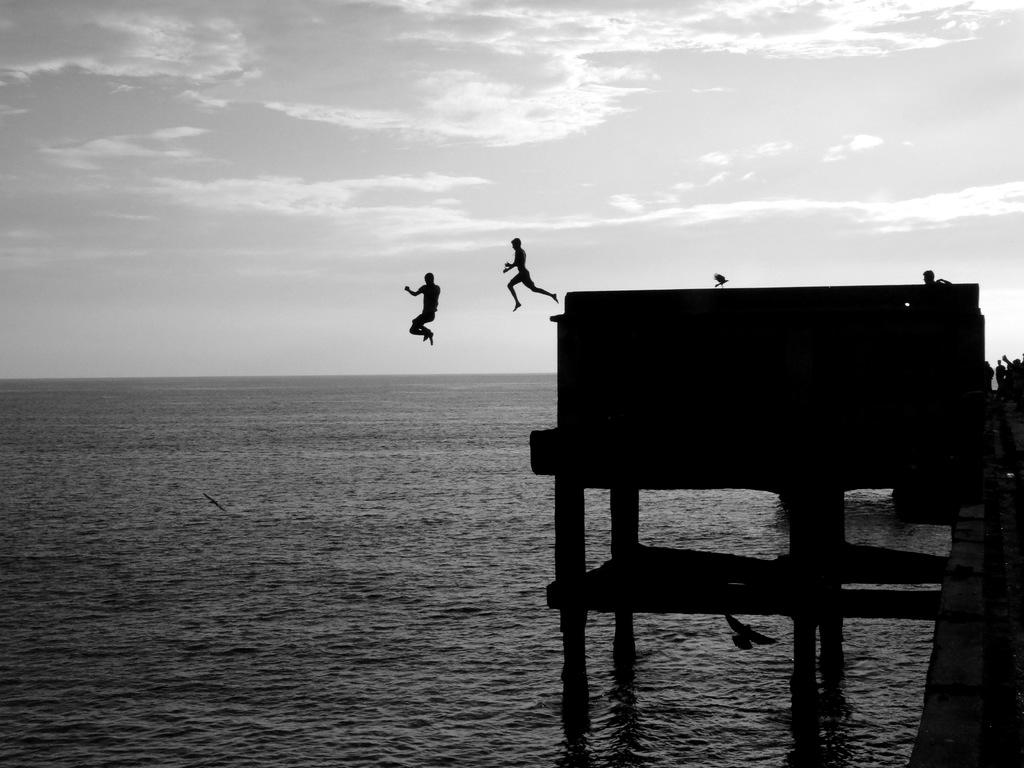Who is present in the image? There are men in the image. What are the men doing in the image? The men are jumping into the water. From where are the men jumping into the water? The jumping action is taking place from a bridge. What else can be seen in the image besides the men? There is a bird visible in the image. What is the primary element in the image? Water is present in the image. What type of quarter is being used by the men to jump into the water? There is no mention of a quarter or any currency being used in the image. The men are jumping into the water from a bridge. What letters are being exchanged between the men as they jump into the water? There is no indication in the image that the men are exchanging letters while jumping into the water. 